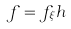Convert formula to latex. <formula><loc_0><loc_0><loc_500><loc_500>f = f _ { \xi } h</formula> 